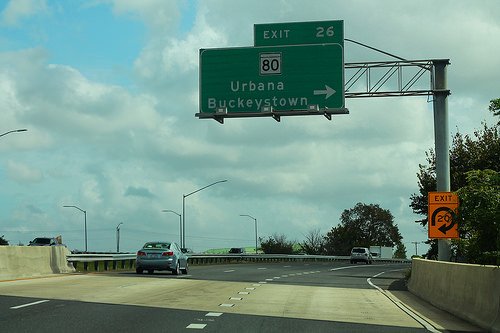<image>
Is there a car under the sign? Yes. The car is positioned underneath the sign, with the sign above it in the vertical space. Where is the bridge in relation to the tree? Is it behind the tree? No. The bridge is not behind the tree. From this viewpoint, the bridge appears to be positioned elsewhere in the scene. Is the sign next to the car? No. The sign is not positioned next to the car. They are located in different areas of the scene. 